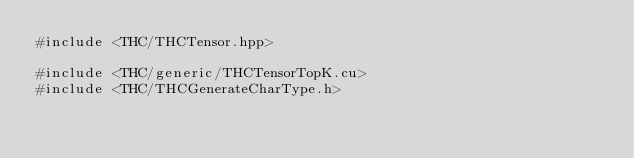Convert code to text. <code><loc_0><loc_0><loc_500><loc_500><_Cuda_>#include <THC/THCTensor.hpp>

#include <THC/generic/THCTensorTopK.cu>
#include <THC/THCGenerateCharType.h>
</code> 